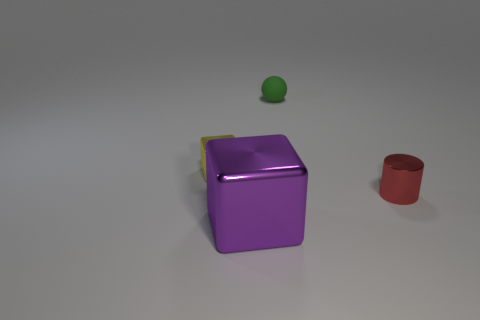Subtract all purple blocks. Subtract all purple cylinders. How many blocks are left? 1 Add 4 yellow shiny cylinders. How many objects exist? 8 Subtract all balls. How many objects are left? 3 Subtract 0 purple cylinders. How many objects are left? 4 Subtract all cylinders. Subtract all tiny yellow things. How many objects are left? 2 Add 1 tiny green rubber things. How many tiny green rubber things are left? 2 Add 4 purple blocks. How many purple blocks exist? 5 